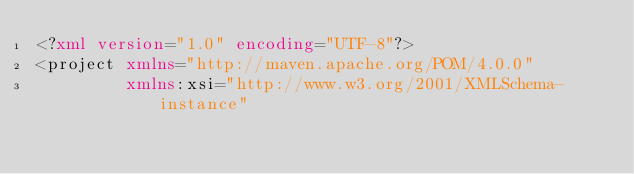<code> <loc_0><loc_0><loc_500><loc_500><_XML_><?xml version="1.0" encoding="UTF-8"?>
<project xmlns="http://maven.apache.org/POM/4.0.0"
         xmlns:xsi="http://www.w3.org/2001/XMLSchema-instance"</code> 